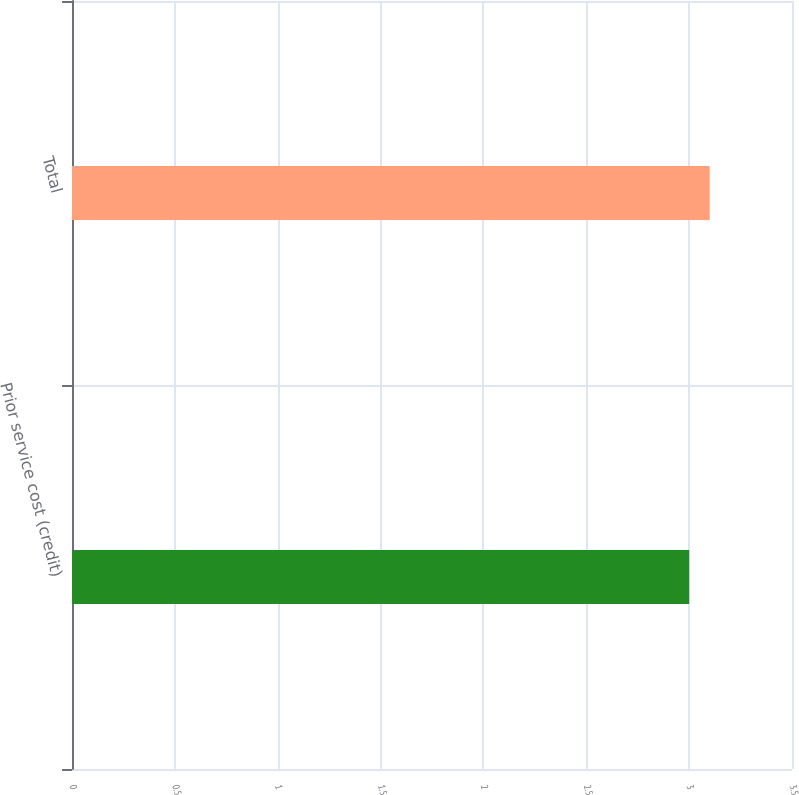Convert chart to OTSL. <chart><loc_0><loc_0><loc_500><loc_500><bar_chart><fcel>Prior service cost (credit)<fcel>Total<nl><fcel>3<fcel>3.1<nl></chart> 